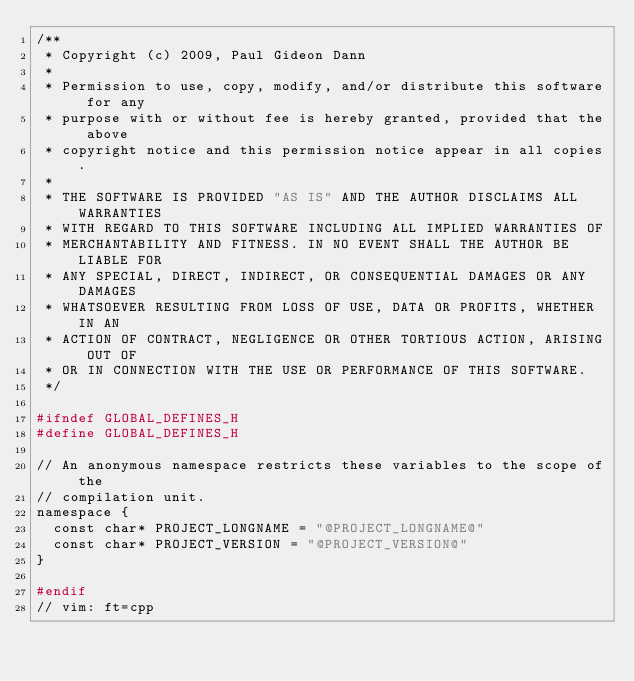<code> <loc_0><loc_0><loc_500><loc_500><_CMake_>/**
 * Copyright (c) 2009, Paul Gideon Dann
 * 
 * Permission to use, copy, modify, and/or distribute this software for any
 * purpose with or without fee is hereby granted, provided that the above
 * copyright notice and this permission notice appear in all copies.
 * 
 * THE SOFTWARE IS PROVIDED "AS IS" AND THE AUTHOR DISCLAIMS ALL WARRANTIES
 * WITH REGARD TO THIS SOFTWARE INCLUDING ALL IMPLIED WARRANTIES OF
 * MERCHANTABILITY AND FITNESS. IN NO EVENT SHALL THE AUTHOR BE LIABLE FOR
 * ANY SPECIAL, DIRECT, INDIRECT, OR CONSEQUENTIAL DAMAGES OR ANY DAMAGES
 * WHATSOEVER RESULTING FROM LOSS OF USE, DATA OR PROFITS, WHETHER IN AN
 * ACTION OF CONTRACT, NEGLIGENCE OR OTHER TORTIOUS ACTION, ARISING OUT OF
 * OR IN CONNECTION WITH THE USE OR PERFORMANCE OF THIS SOFTWARE.
 */

#ifndef GLOBAL_DEFINES_H
#define GLOBAL_DEFINES_H

// An anonymous namespace restricts these variables to the scope of the
// compilation unit.
namespace {
  const char* PROJECT_LONGNAME = "@PROJECT_LONGNAME@"
  const char* PROJECT_VERSION = "@PROJECT_VERSION@"
}

#endif
// vim: ft=cpp
</code> 